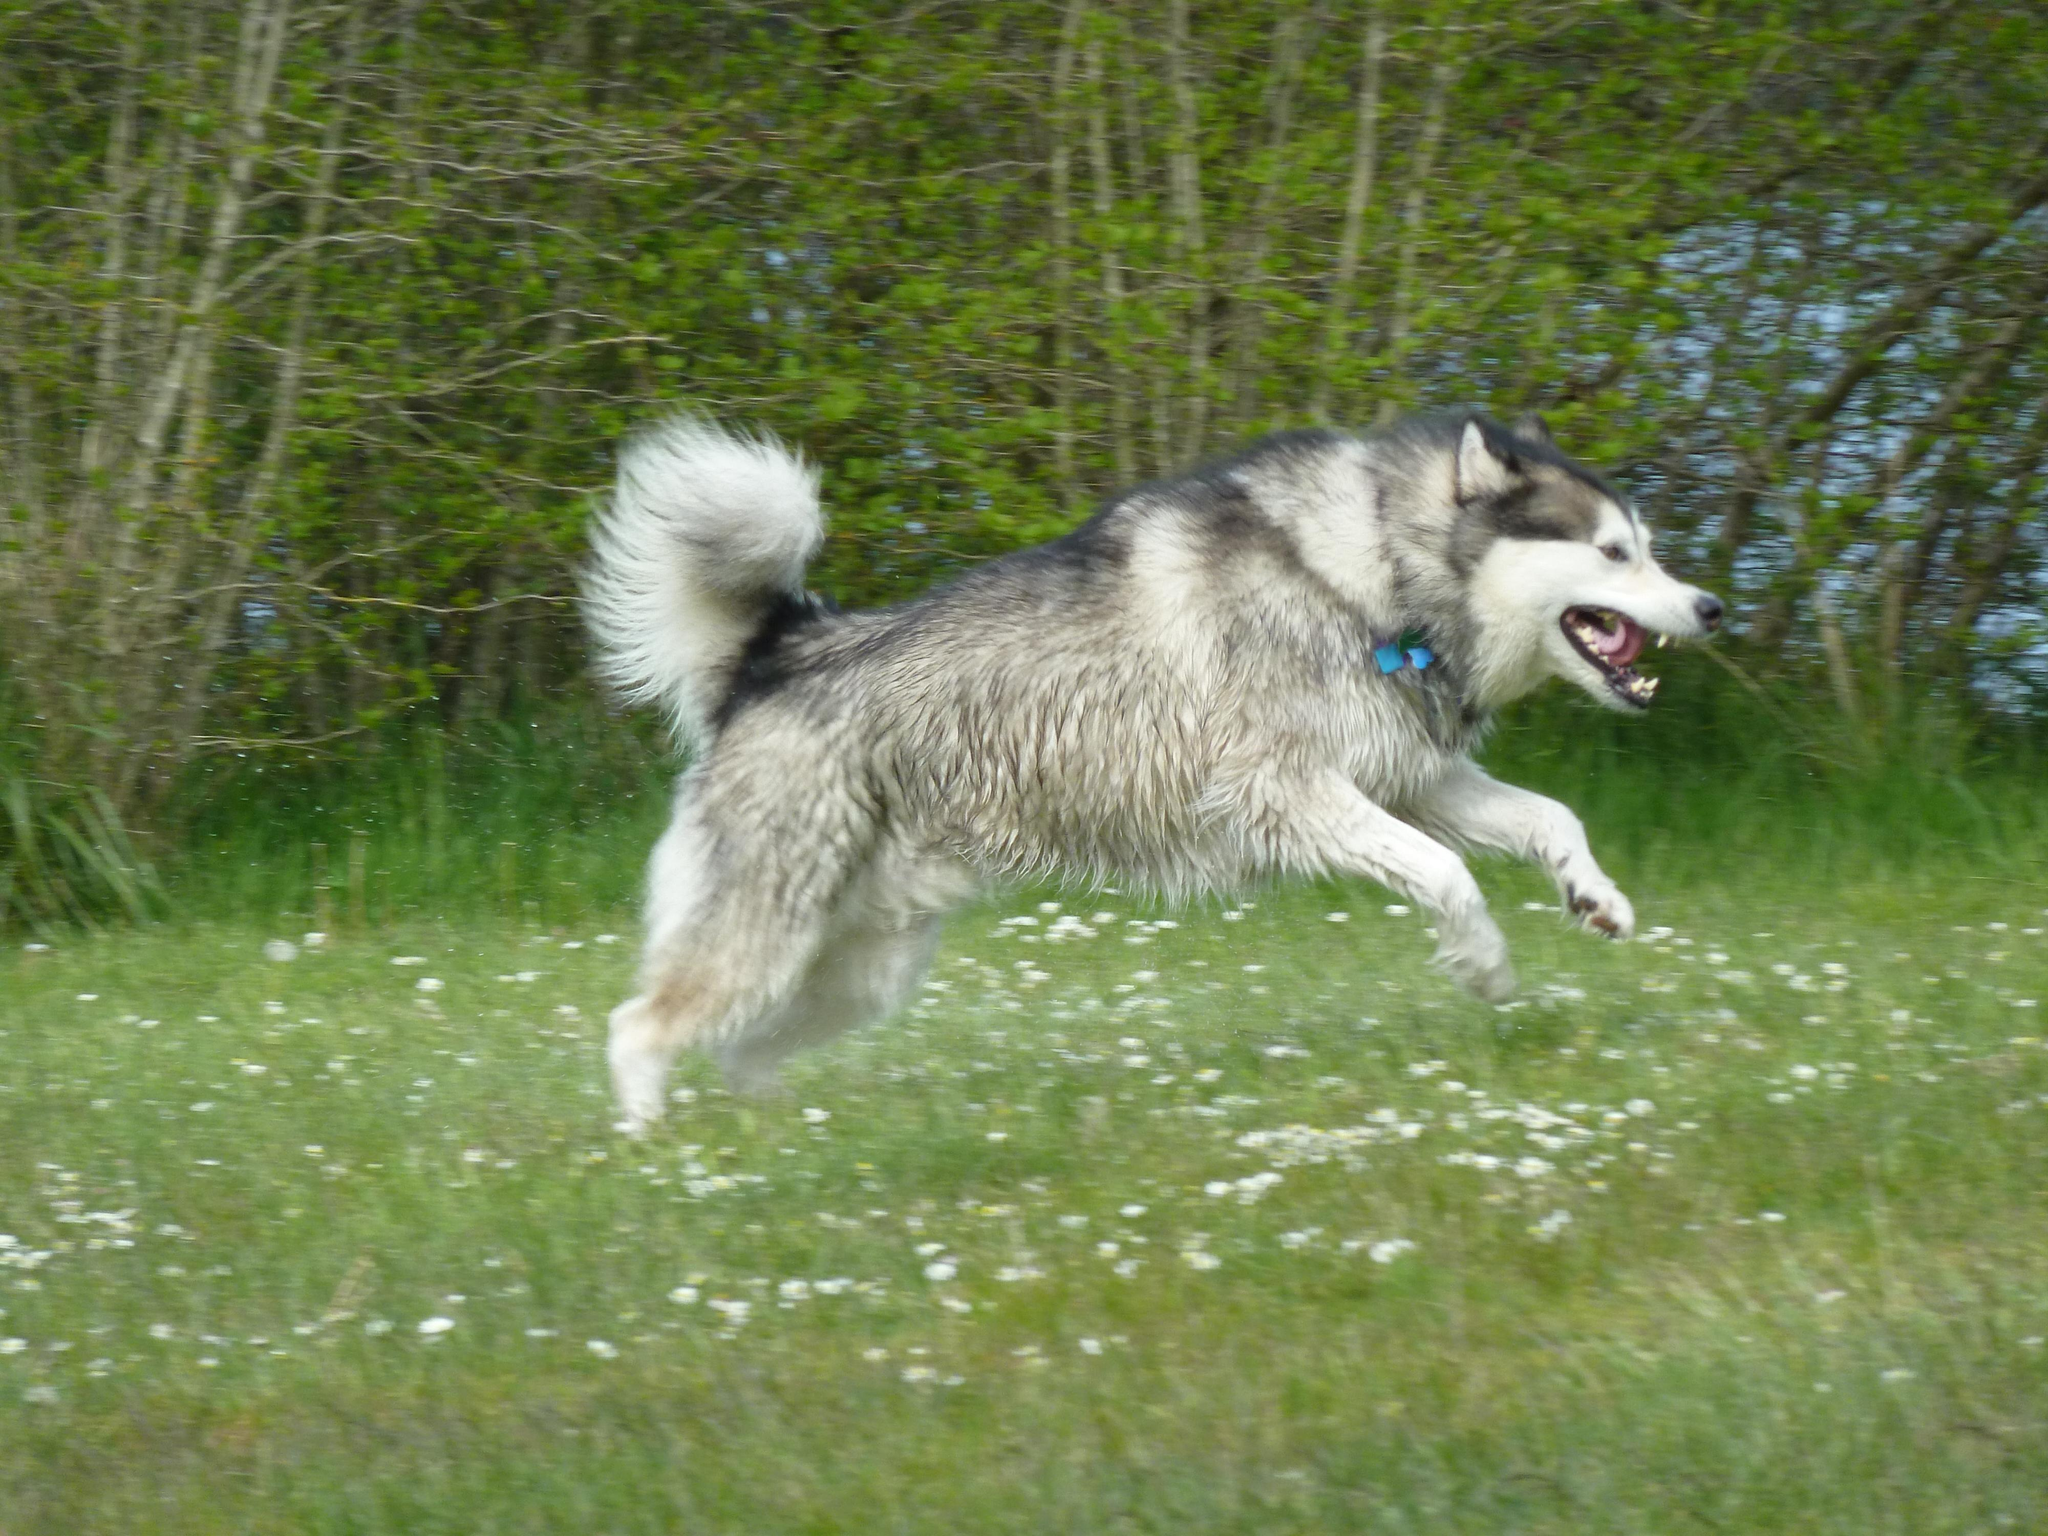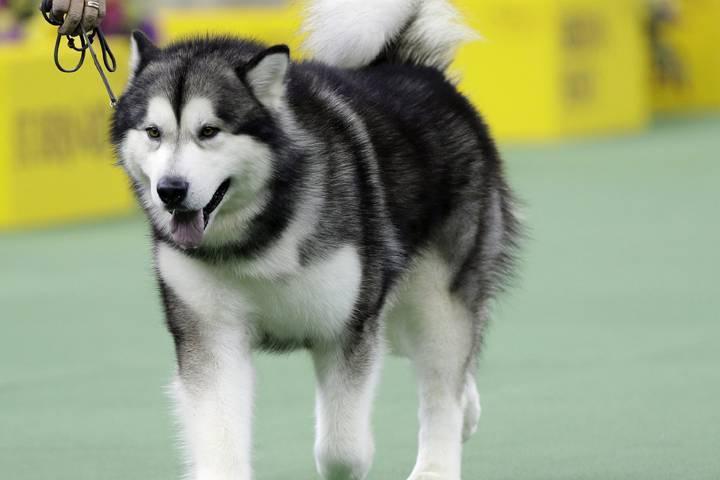The first image is the image on the left, the second image is the image on the right. Analyze the images presented: Is the assertion "The husky is holding something in its mouth." valid? Answer yes or no. No. 